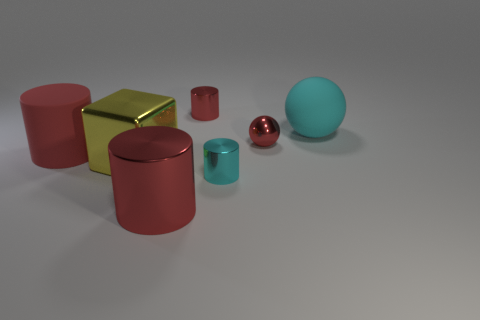What number of rubber objects are blue spheres or red cylinders?
Offer a very short reply. 1. Are there any red balls that have the same material as the cyan ball?
Offer a very short reply. No. What number of things are red cylinders right of the big red metal thing or objects that are in front of the large block?
Provide a succinct answer. 3. Do the tiny cylinder that is behind the small cyan shiny cylinder and the small sphere have the same color?
Offer a very short reply. Yes. How many other objects are the same color as the matte sphere?
Offer a terse response. 1. What is the large ball made of?
Give a very brief answer. Rubber. There is a cyan thing behind the matte cylinder; is it the same size as the small cyan metal cylinder?
Provide a short and direct response. No. There is a cyan object that is the same shape as the red matte object; what is its size?
Ensure brevity in your answer.  Small. Are there an equal number of small red metal cylinders on the right side of the cyan metal object and big matte things that are in front of the cyan sphere?
Offer a terse response. No. How big is the metallic cylinder that is behind the big yellow metallic thing?
Give a very brief answer. Small. 